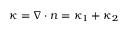<formula> <loc_0><loc_0><loc_500><loc_500>\kappa = \nabla \cdot n = \kappa _ { 1 } + \kappa _ { 2 }</formula> 